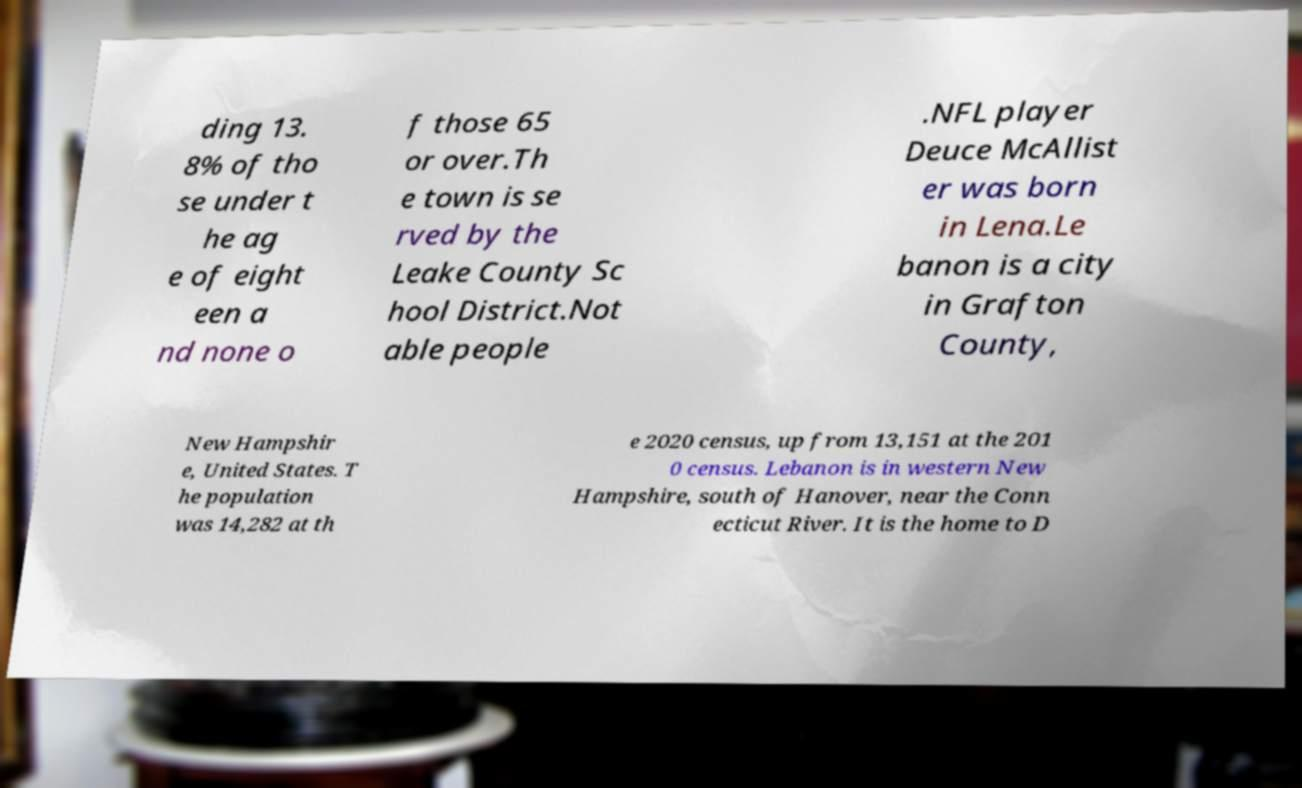For documentation purposes, I need the text within this image transcribed. Could you provide that? ding 13. 8% of tho se under t he ag e of eight een a nd none o f those 65 or over.Th e town is se rved by the Leake County Sc hool District.Not able people .NFL player Deuce McAllist er was born in Lena.Le banon is a city in Grafton County, New Hampshir e, United States. T he population was 14,282 at th e 2020 census, up from 13,151 at the 201 0 census. Lebanon is in western New Hampshire, south of Hanover, near the Conn ecticut River. It is the home to D 